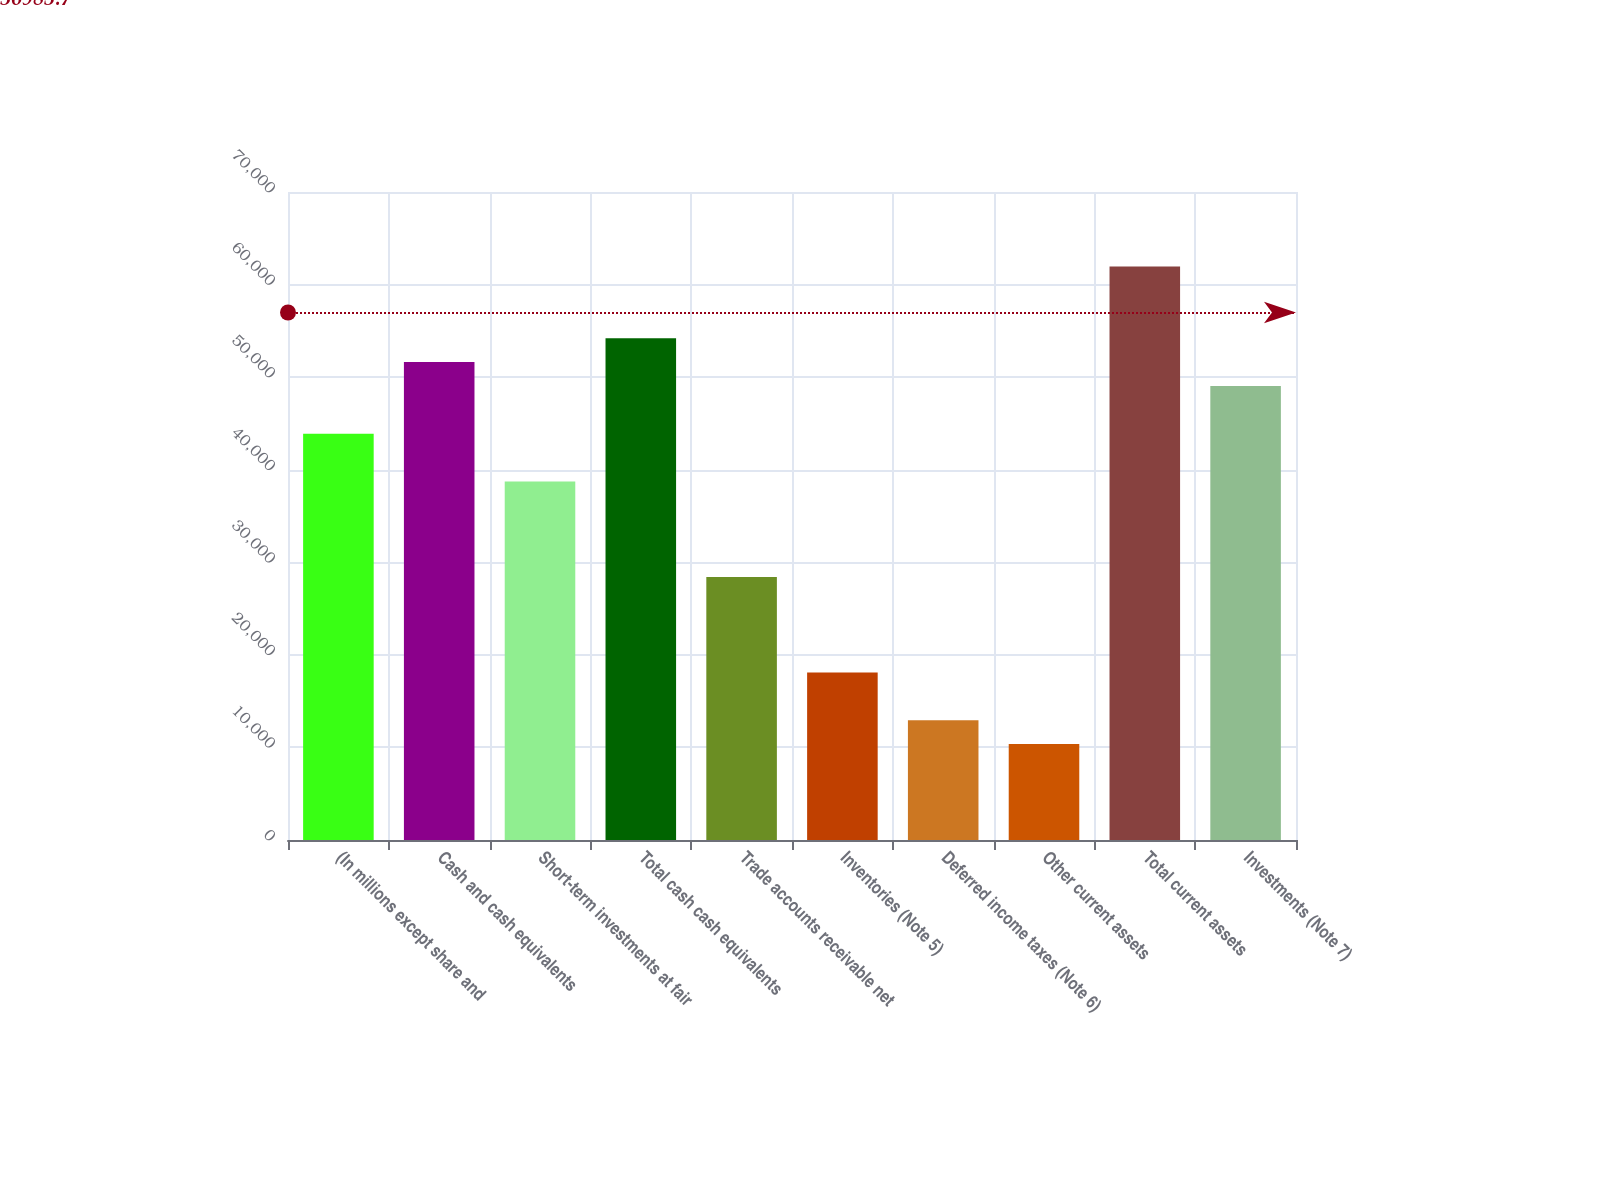<chart> <loc_0><loc_0><loc_500><loc_500><bar_chart><fcel>(In millions except share and<fcel>Cash and cash equivalents<fcel>Short-term investments at fair<fcel>Total cash cash equivalents<fcel>Trade accounts receivable net<fcel>Inventories (Note 5)<fcel>Deferred income taxes (Note 6)<fcel>Other current assets<fcel>Total current assets<fcel>Investments (Note 7)<nl><fcel>43886<fcel>51623<fcel>38728<fcel>54202<fcel>28412<fcel>18096<fcel>12938<fcel>10359<fcel>61939<fcel>49044<nl></chart> 